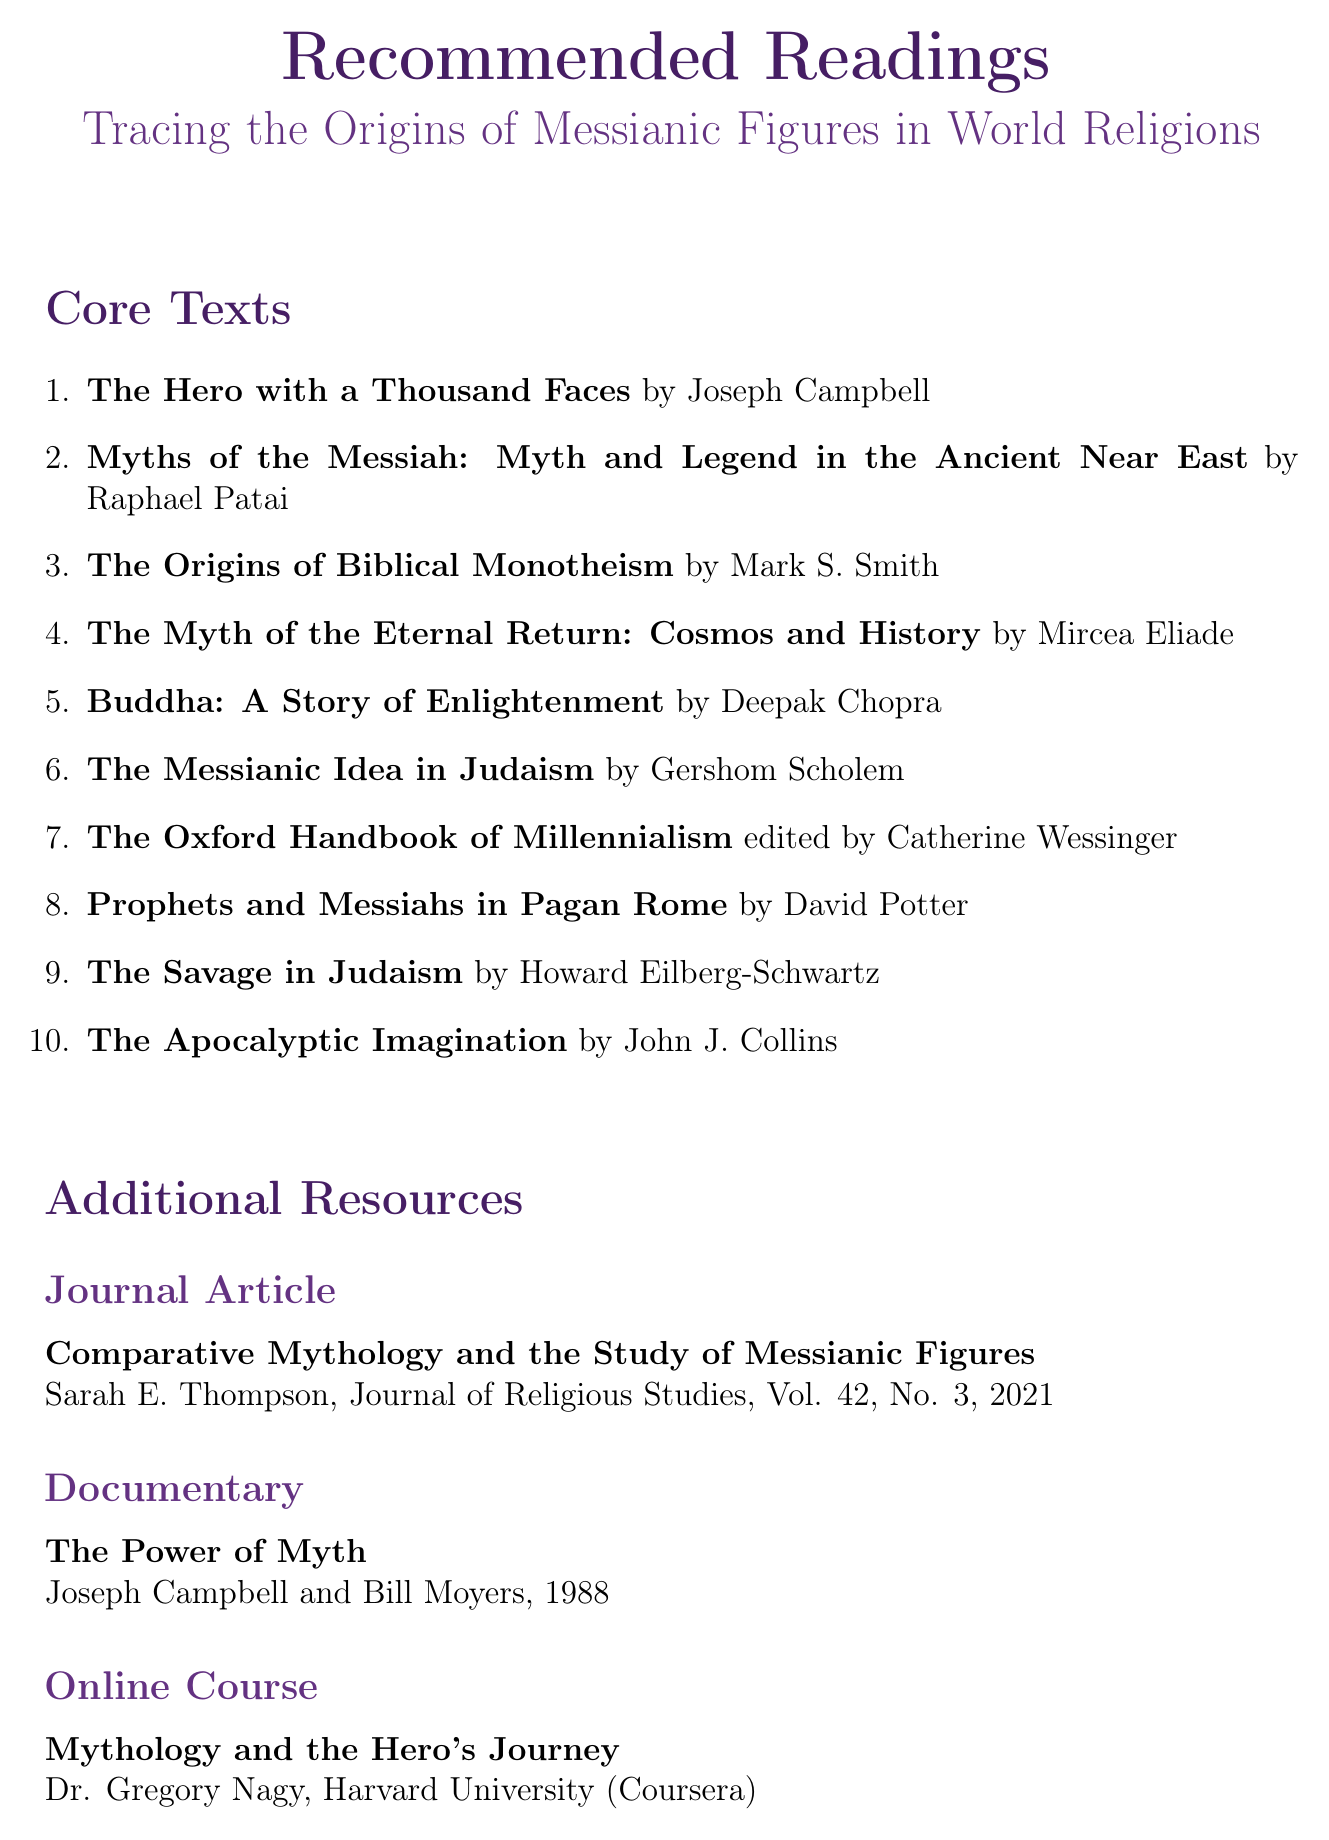What is the title of the seminar? The title of the seminar is explicitly stated in the document.
Answer: Tracing the Origins of Messianic Figures in World Religions Who is the author of "The Hero with a Thousand Faces"? This information is given in the recommended readings section of the document.
Answer: Joseph Campbell What year was "The Power of Myth" released? The release year is specified in the additional resources section of the document.
Answer: 1988 How many core texts are listed in the recommended readings? The total number can be counted from the enumerated list in the document.
Answer: 10 What is the subject of "The Myth of the Eternal Return"? This description outlines the main focus of the book in the document.
Answer: Analysis of cyclical time and the concept of eternal return Name one of the recommended readings that discusses messianic traditions in the ancient Near East. The document provides specific titles in this context.
Answer: Myths of the Messiah: Myth and Legend in the Ancient Near East Who edited "The Oxford Handbook of Millennialism"? The document specifies the editor of this resource.
Answer: Catherine Wessinger What type of resource is the "Mythology and the Hero's Journey"? The document categorizes resources, allowing identification of the type.
Answer: Online Course Name one author who examines messianic concepts in Jewish mysticism. The document lists relevant authors in the description of their works.
Answer: Gershom Scholem 